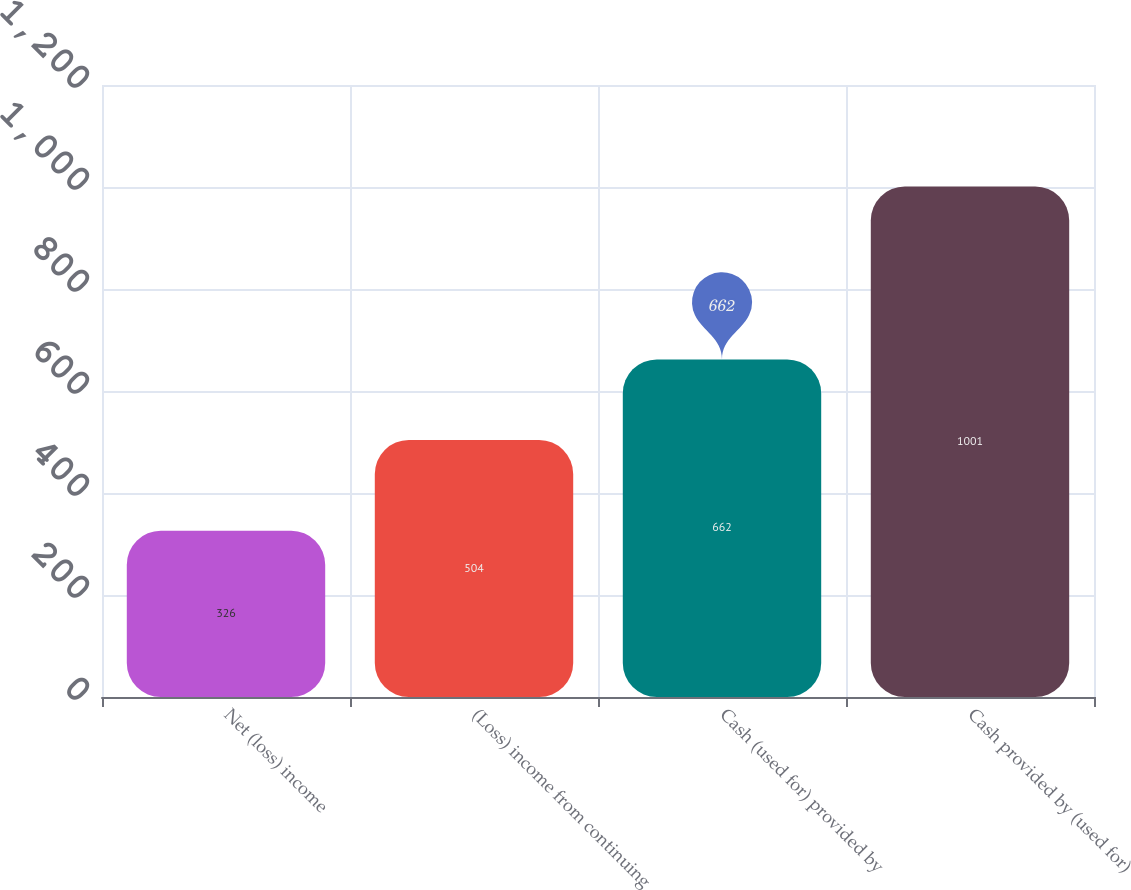Convert chart to OTSL. <chart><loc_0><loc_0><loc_500><loc_500><bar_chart><fcel>Net (loss) income<fcel>(Loss) income from continuing<fcel>Cash (used for) provided by<fcel>Cash provided by (used for)<nl><fcel>326<fcel>504<fcel>662<fcel>1001<nl></chart> 